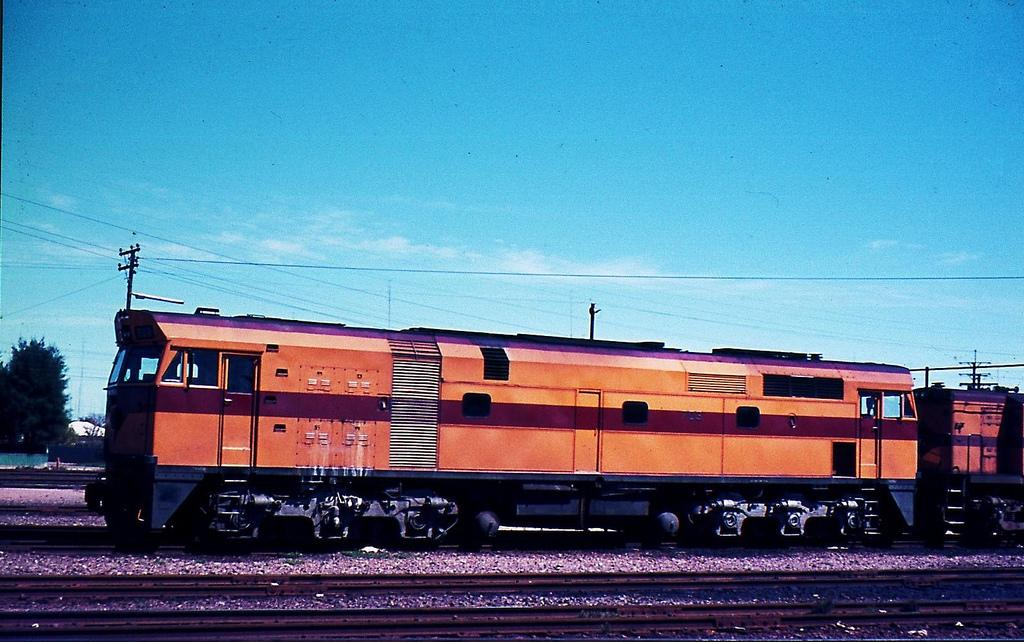What is the main subject of the image? The main subject of the image is a train. Where is the train located in the image? The train is on a railway track. What else can be seen in the image besides the train? There are wires, poles, a tree, and the sky visible in the image. What is the condition of the sky in the image? The sky is visible in the background of the image, and clouds are present. Can you tell me how many bowls of soup are being served on the train in the image? There is no information about soup or any food being served on the train in the image. 